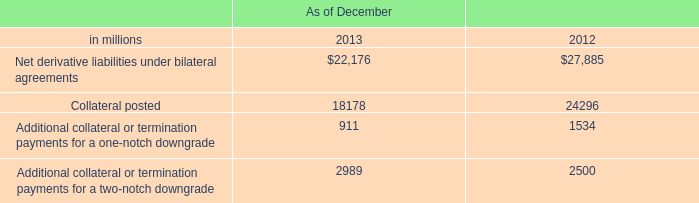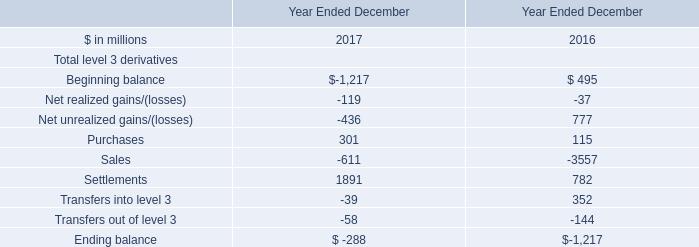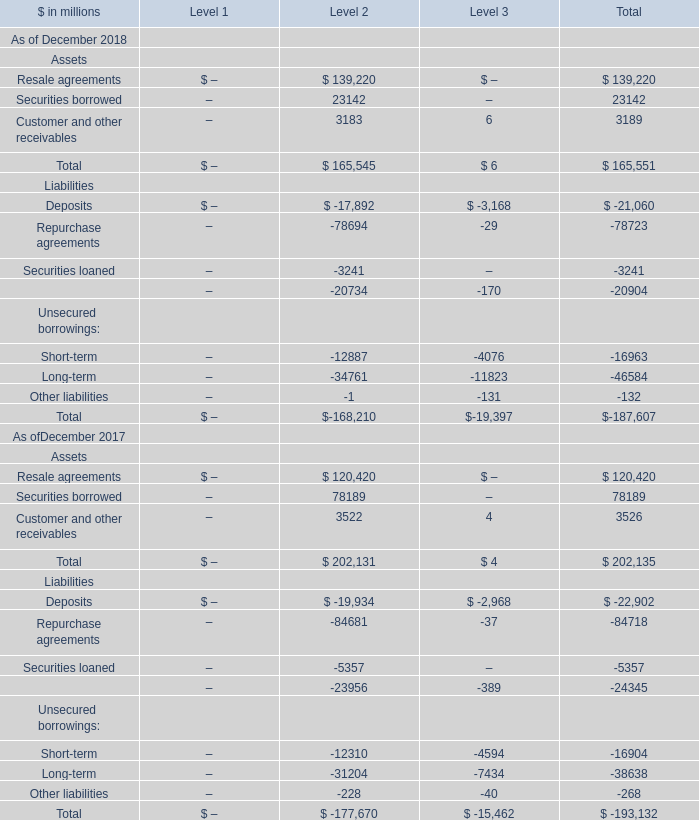What is the total amount of Repurchase agreements Liabilities of Level 2, Sales of Year Ended December 2016, and Securities loaned Liabilities of Level 2 ? 
Computations: ((84681.0 + 3557.0) + 3241.0)
Answer: 91479.0. 